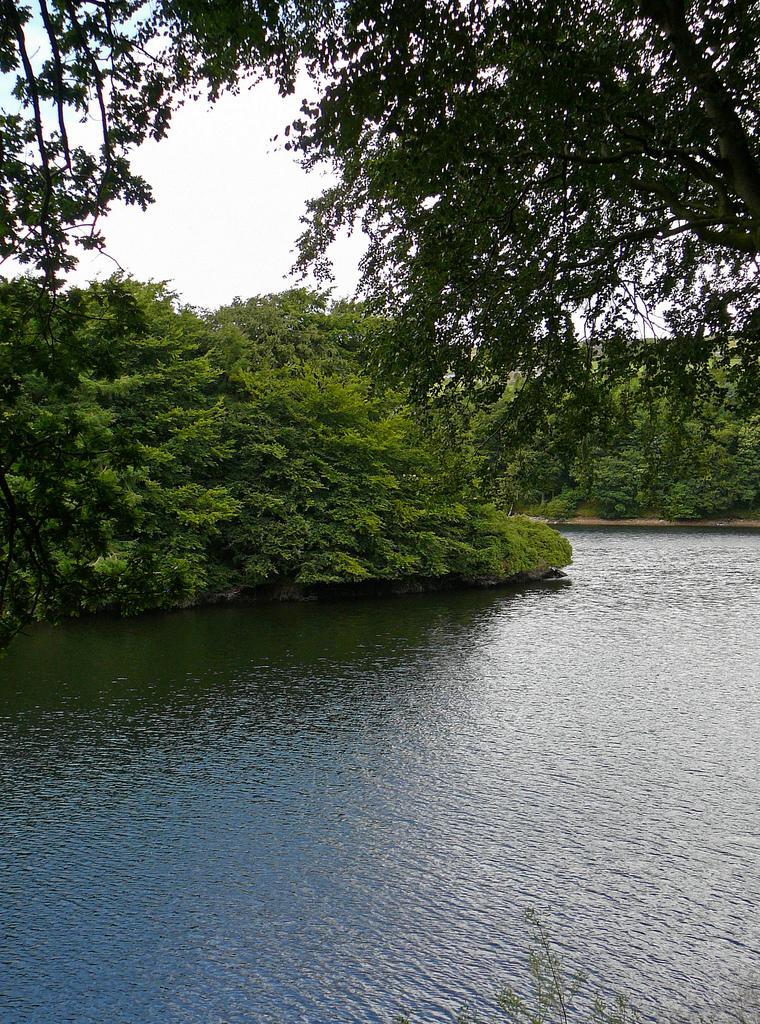Can you describe this image briefly? In this image there is water, in the background of the image there are trees. 